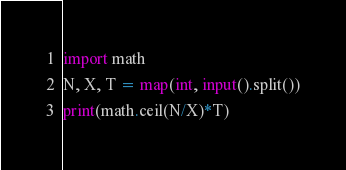Convert code to text. <code><loc_0><loc_0><loc_500><loc_500><_Python_>import math
N, X, T = map(int, input().split())
print(math.ceil(N/X)*T)
</code> 